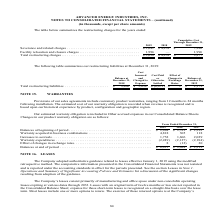According to Advanced Energy's financial document, How does the company record the estimated cost of warranty obligation? when revenue is recognized and is based upon our historical experience by product, configuration and geographic region.. The document states: "imated cost of our warranty obligation is recorded when revenue is recognized and is based upon our historical experience by product, configuration an..." Also, What are the years included in the table for Changes in our product warranty obligation The document contains multiple relevant values: 2019, 2018, 2017. From the document: "Years Ended December 31, 2019 2018 2017 Years Ended December 31, 2019 2018 2017 Years Ended December 31, 2019 2018 2017..." Also, What was the balance at the beginning of period in 2017? According to the financial document, $2,329 (in thousands). The relevant text states: "lances at beginning of period . $ 2,084 $ 2,312 $ 2,329 Warranty acquired in business combinations . 4,818 305 118 Increases to accruals . 1,752 1,606 2,02..." Also, can you calculate: What was the change in warranty acquired in business combinations between 2018 and 2019? Based on the calculation: 4,818-305, the result is 4513 (in thousands). This is based on the information: ",329 Warranty acquired in business combinations . 4,818 305 118 Increases to accruals . 1,752 1,606 2,029 Warranty expenditures . (2,249) (2,127) (2,184) E arranty acquired in business combinations . ..." The key data points involved are: 305, 4,818. Also, can you calculate: What was the Increases to accruals between 2017 and 2018? Based on the calculation: 1,606-2,029, the result is -423 (in thousands). This is based on the information: "4,818 305 118 Increases to accruals . 1,752 1,606 2,029 Warranty expenditures . (2,249) (2,127) (2,184) Effect of changes in exchange rates . 8 (12) 20 Bal ons . 4,818 305 118 Increases to accruals . ..." The key data points involved are: 1,606, 2,029. Also, can you calculate: What was the percentage change in balances at end of period between 2018 and 2019? To answer this question, I need to perform calculations using the financial data. The calculation is: ($6,413-$2,084)/$2,084, which equals 207.73 (percentage). This is based on the information: "Balances at beginning of period . $ 2,084 $ 2,312 $ 2,329 Warranty acquired in business combinations . 4,818 305 118 Increases to accruals . e rates . 8 (12) 20 Balances at end of period . $ 6,413 $ 2..." The key data points involved are: 2,084, 6,413. 